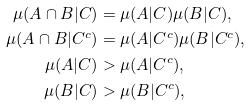<formula> <loc_0><loc_0><loc_500><loc_500>\mu ( A \cap B | C ) & = \mu ( A | C ) \mu ( B | C ) , \\ \mu ( A \cap B | C ^ { c } ) & = \mu ( A | C ^ { c } ) \mu ( B | C ^ { c } ) , \\ \mu ( A | C ) & > \mu ( A | C ^ { c } ) , \\ \mu ( B | C ) & > \mu ( B | C ^ { c } ) ,</formula> 